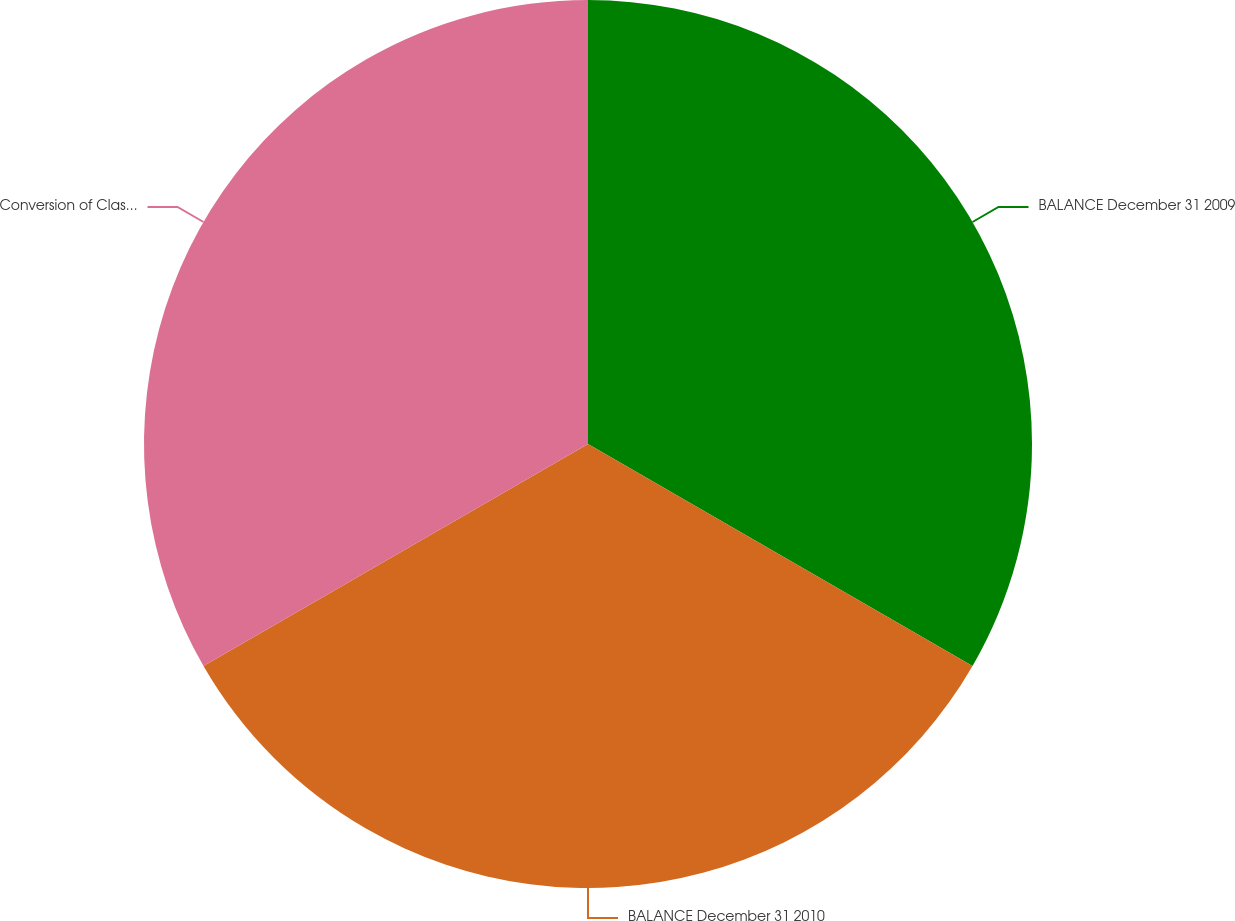<chart> <loc_0><loc_0><loc_500><loc_500><pie_chart><fcel>BALANCE December 31 2009<fcel>BALANCE December 31 2010<fcel>Conversion of Class B common<nl><fcel>33.33%<fcel>33.33%<fcel>33.33%<nl></chart> 